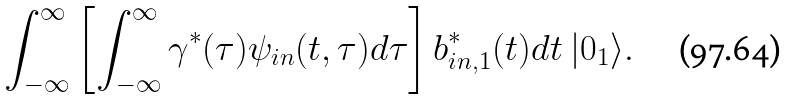<formula> <loc_0><loc_0><loc_500><loc_500>\int _ { - \infty } ^ { \infty } \left [ \int _ { - \infty } ^ { \infty } \gamma ^ { \ast } ( \tau ) \psi _ { i n } ( t , \tau ) d \tau \right ] b _ { i n , 1 } ^ { \ast } ( t ) d t \ | 0 _ { 1 } \rangle .</formula> 